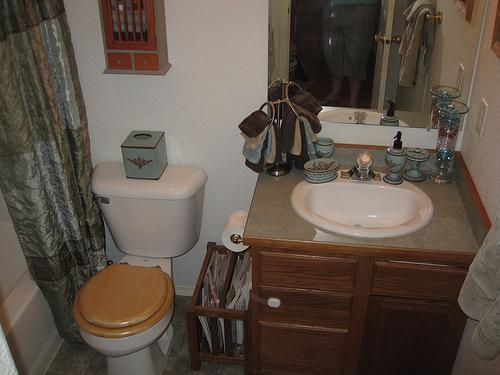How many boxes are there?
Give a very brief answer. 1. 